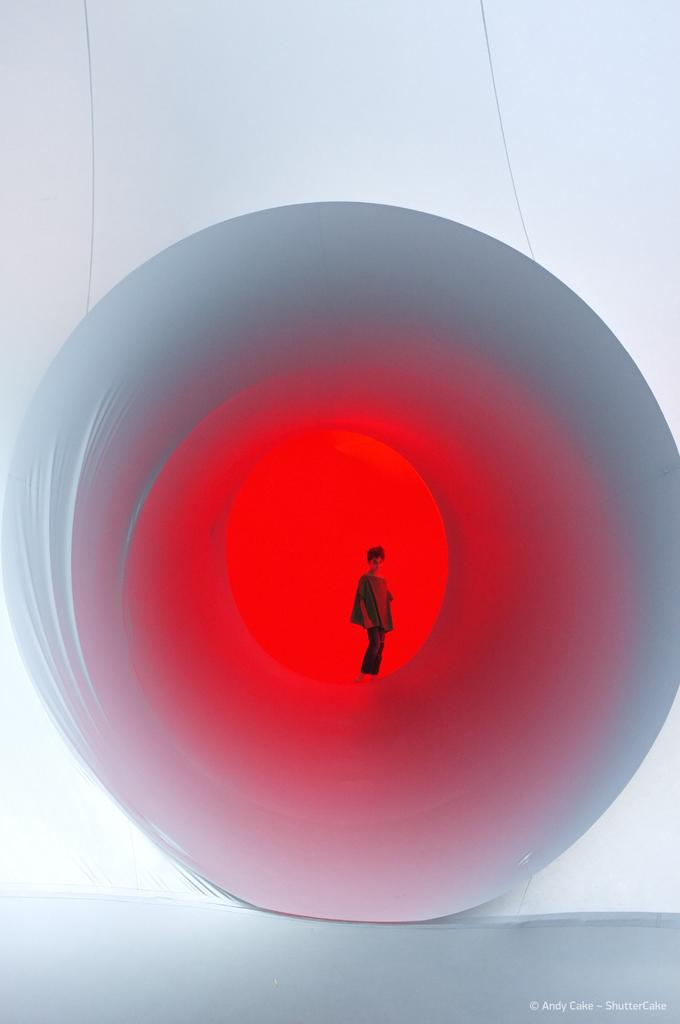What type of image is being described? The image is animated. Can you describe the main subject in the image? There is a person in the middle of the image. What colors are present in the background of the image? The background of the image includes red and white colors. What type of calendar is displayed on the wall in the image? There is no calendar present in the image. How does the person's wealth affect the scene in the image? The image does not provide any information about the person's wealth, so we cannot determine its impact on the scene. 